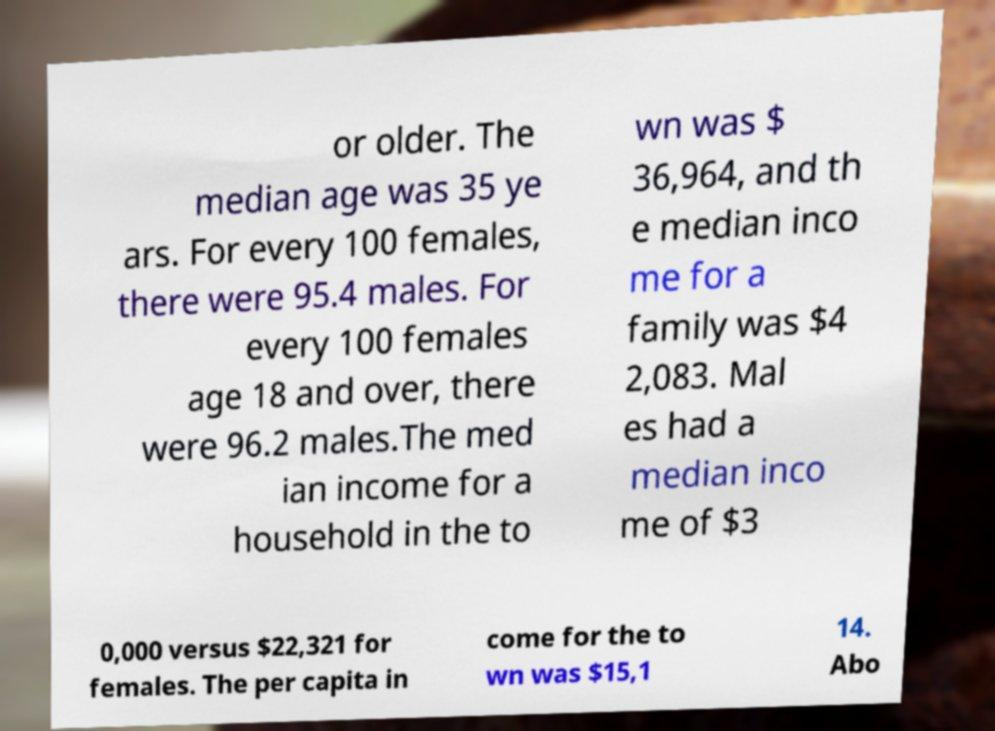Could you assist in decoding the text presented in this image and type it out clearly? or older. The median age was 35 ye ars. For every 100 females, there were 95.4 males. For every 100 females age 18 and over, there were 96.2 males.The med ian income for a household in the to wn was $ 36,964, and th e median inco me for a family was $4 2,083. Mal es had a median inco me of $3 0,000 versus $22,321 for females. The per capita in come for the to wn was $15,1 14. Abo 